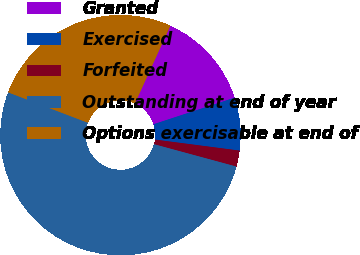Convert chart to OTSL. <chart><loc_0><loc_0><loc_500><loc_500><pie_chart><fcel>Granted<fcel>Exercised<fcel>Forfeited<fcel>Outstanding at end of year<fcel>Options exercisable at end of<nl><fcel>13.15%<fcel>7.1%<fcel>2.16%<fcel>51.57%<fcel>26.01%<nl></chart> 